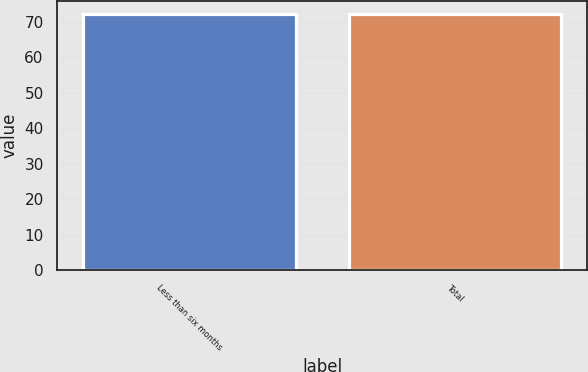<chart> <loc_0><loc_0><loc_500><loc_500><bar_chart><fcel>Less than six months<fcel>Total<nl><fcel>72<fcel>72.1<nl></chart> 